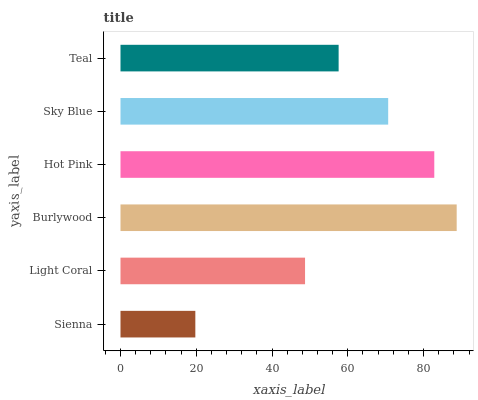Is Sienna the minimum?
Answer yes or no. Yes. Is Burlywood the maximum?
Answer yes or no. Yes. Is Light Coral the minimum?
Answer yes or no. No. Is Light Coral the maximum?
Answer yes or no. No. Is Light Coral greater than Sienna?
Answer yes or no. Yes. Is Sienna less than Light Coral?
Answer yes or no. Yes. Is Sienna greater than Light Coral?
Answer yes or no. No. Is Light Coral less than Sienna?
Answer yes or no. No. Is Sky Blue the high median?
Answer yes or no. Yes. Is Teal the low median?
Answer yes or no. Yes. Is Burlywood the high median?
Answer yes or no. No. Is Burlywood the low median?
Answer yes or no. No. 